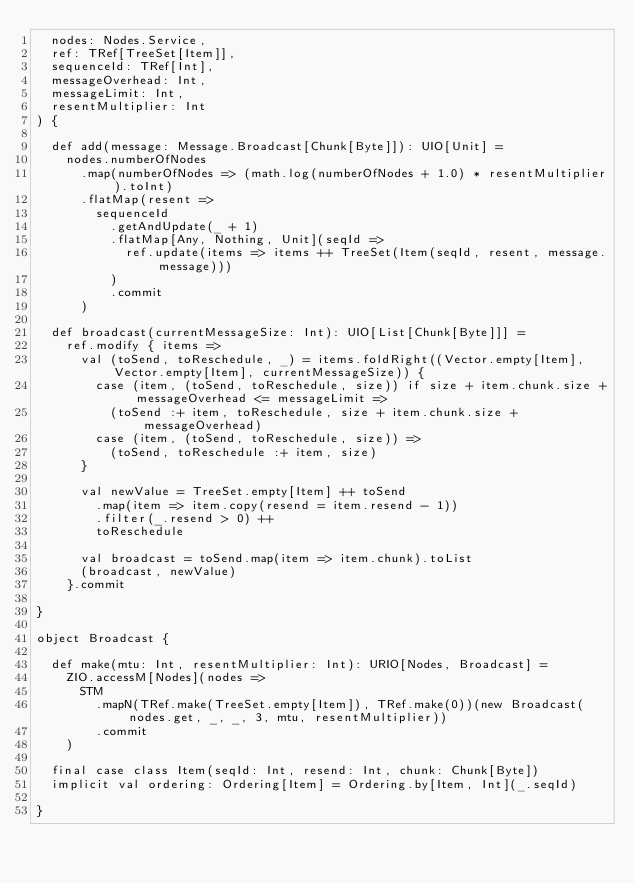<code> <loc_0><loc_0><loc_500><loc_500><_Scala_>  nodes: Nodes.Service,
  ref: TRef[TreeSet[Item]],
  sequenceId: TRef[Int],
  messageOverhead: Int,
  messageLimit: Int,
  resentMultiplier: Int
) {

  def add(message: Message.Broadcast[Chunk[Byte]]): UIO[Unit] =
    nodes.numberOfNodes
      .map(numberOfNodes => (math.log(numberOfNodes + 1.0) * resentMultiplier).toInt)
      .flatMap(resent =>
        sequenceId
          .getAndUpdate(_ + 1)
          .flatMap[Any, Nothing, Unit](seqId =>
            ref.update(items => items ++ TreeSet(Item(seqId, resent, message.message)))
          )
          .commit
      )

  def broadcast(currentMessageSize: Int): UIO[List[Chunk[Byte]]] =
    ref.modify { items =>
      val (toSend, toReschedule, _) = items.foldRight((Vector.empty[Item], Vector.empty[Item], currentMessageSize)) {
        case (item, (toSend, toReschedule, size)) if size + item.chunk.size + messageOverhead <= messageLimit =>
          (toSend :+ item, toReschedule, size + item.chunk.size + messageOverhead)
        case (item, (toSend, toReschedule, size)) =>
          (toSend, toReschedule :+ item, size)
      }

      val newValue = TreeSet.empty[Item] ++ toSend
        .map(item => item.copy(resend = item.resend - 1))
        .filter(_.resend > 0) ++
        toReschedule

      val broadcast = toSend.map(item => item.chunk).toList
      (broadcast, newValue)
    }.commit

}

object Broadcast {

  def make(mtu: Int, resentMultiplier: Int): URIO[Nodes, Broadcast] =
    ZIO.accessM[Nodes](nodes =>
      STM
        .mapN(TRef.make(TreeSet.empty[Item]), TRef.make(0))(new Broadcast(nodes.get, _, _, 3, mtu, resentMultiplier))
        .commit
    )

  final case class Item(seqId: Int, resend: Int, chunk: Chunk[Byte])
  implicit val ordering: Ordering[Item] = Ordering.by[Item, Int](_.seqId)

}
</code> 